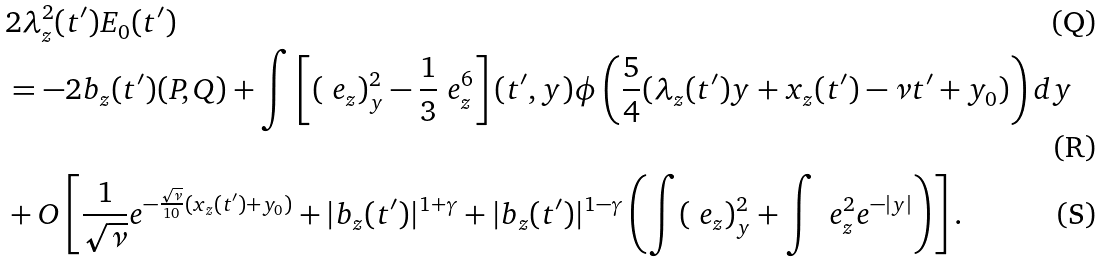Convert formula to latex. <formula><loc_0><loc_0><loc_500><loc_500>& 2 \lambda ^ { 2 } _ { z } ( t ^ { \prime } ) E _ { 0 } ( t ^ { \prime } ) \\ & = - 2 b _ { z } ( t ^ { \prime } ) ( P , Q ) + \int \left [ ( \ e _ { z } ) _ { y } ^ { 2 } - \frac { 1 } { 3 } \ e _ { z } ^ { 6 } \right ] ( t ^ { \prime } , y ) \phi \left ( \frac { 5 } { 4 } ( \lambda _ { z } ( t ^ { \prime } ) y + x _ { z } ( t ^ { \prime } ) - \nu t ^ { \prime } + { y _ { 0 } } ) \right ) d y \\ & + O \left [ \frac { 1 } { \sqrt { \nu } } e ^ { - \frac { \sqrt { \nu } } { 1 0 } ( x _ { z } ( t ^ { \prime } ) + y _ { 0 } ) } + { | b _ { z } ( t ^ { \prime } ) | ^ { 1 + \gamma } } + | b _ { z } ( t ^ { \prime } ) | ^ { 1 - \gamma } \left ( \int ( \ e _ { z } ) _ { y } ^ { 2 } + \int \ e _ { z } ^ { 2 } { e ^ { - | y | } } \right ) \right ] .</formula> 